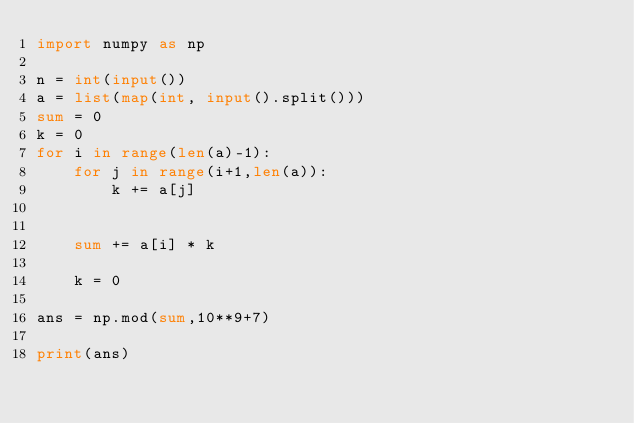Convert code to text. <code><loc_0><loc_0><loc_500><loc_500><_Python_>import numpy as np

n = int(input())
a = list(map(int, input().split()))
sum = 0
k = 0
for i in range(len(a)-1):
    for j in range(i+1,len(a)):
        k += a[j]

    
    sum += a[i] * k

    k = 0
        
ans = np.mod(sum,10**9+7)

print(ans)

</code> 